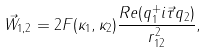Convert formula to latex. <formula><loc_0><loc_0><loc_500><loc_500>\vec { W } _ { 1 , 2 } = 2 F ( \kappa _ { 1 } , \kappa _ { 2 } ) \frac { R e ( q _ { 1 } ^ { + } i \vec { \tau } q _ { 2 } ) } { r _ { 1 2 } ^ { 2 } } ,</formula> 